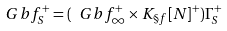<formula> <loc_0><loc_0><loc_500><loc_500>\ G b f _ { S } ^ { + } = ( \ G b f _ { \infty } ^ { + } \times K _ { \S f } [ N ] ^ { + } ) \Gamma _ { S } ^ { + }</formula> 